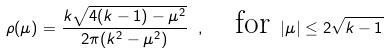<formula> <loc_0><loc_0><loc_500><loc_500>\rho ( \mu ) = \frac { k \sqrt { 4 ( k - 1 ) - \mu ^ { 2 } } } { 2 \pi ( k ^ { 2 } - \mu ^ { 2 } ) } \ , \quad \text {for } | \mu | \leq 2 \sqrt { k - 1 }</formula> 